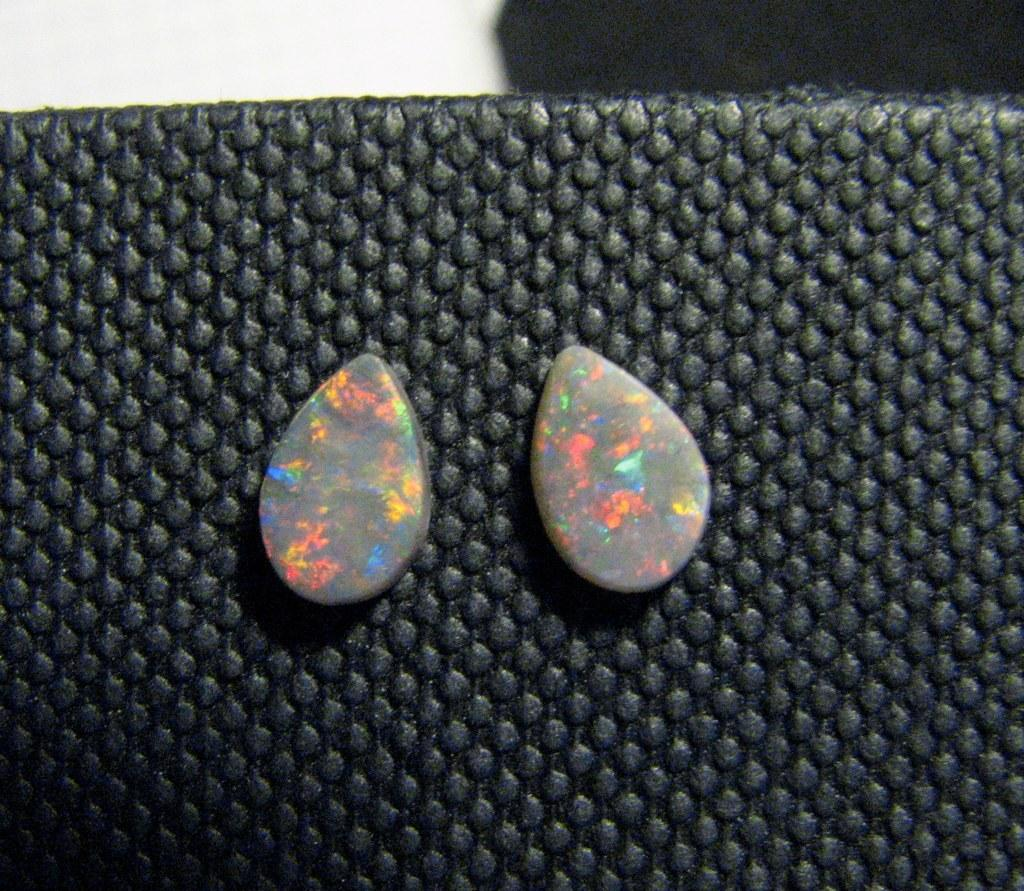What type of objects are in the image? There are stones in the image. Where are the stones located? The stones are on a mat. What type of rhythm can be heard coming from the stones in the image? There is no sound or rhythm associated with the stones in the image. 